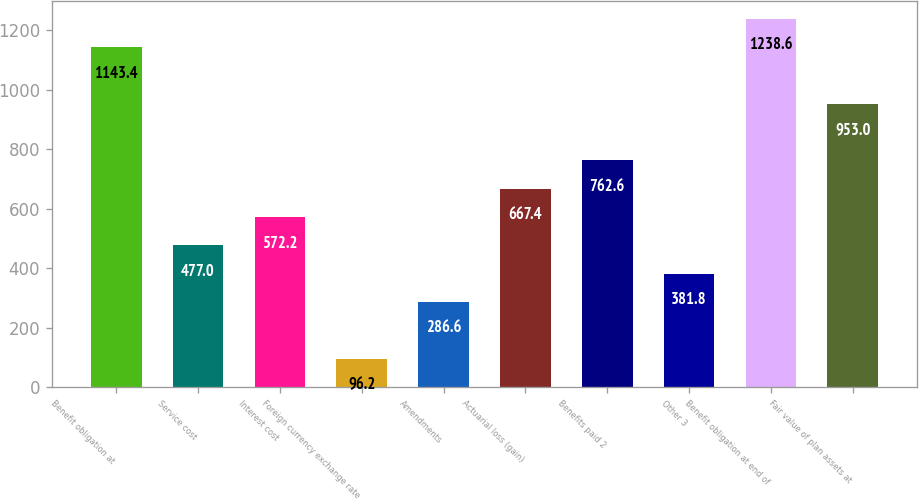<chart> <loc_0><loc_0><loc_500><loc_500><bar_chart><fcel>Benefit obligation at<fcel>Service cost<fcel>Interest cost<fcel>Foreign currency exchange rate<fcel>Amendments<fcel>Actuarial loss (gain)<fcel>Benefits paid 2<fcel>Other 3<fcel>Benefit obligation at end of<fcel>Fair value of plan assets at<nl><fcel>1143.4<fcel>477<fcel>572.2<fcel>96.2<fcel>286.6<fcel>667.4<fcel>762.6<fcel>381.8<fcel>1238.6<fcel>953<nl></chart> 